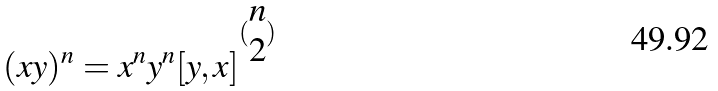<formula> <loc_0><loc_0><loc_500><loc_500>( x y ) ^ { n } = x ^ { n } y ^ { n } [ y , x ] ^ { ( \begin{matrix} n \\ 2 \end{matrix} ) }</formula> 